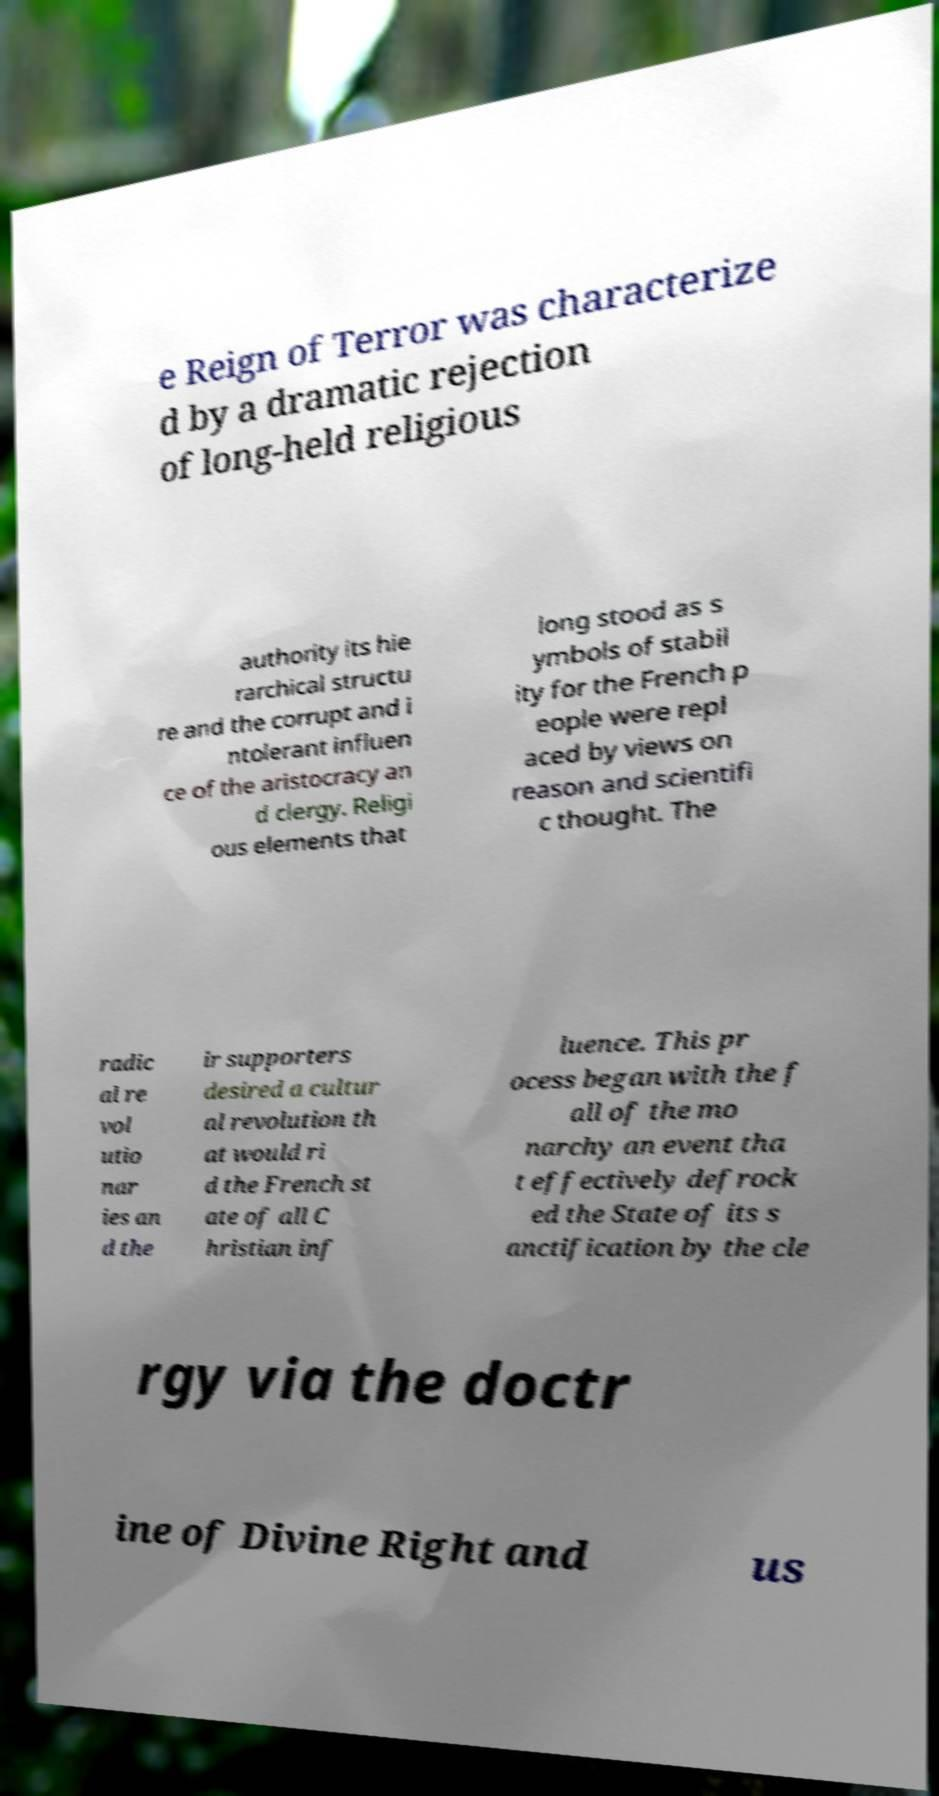Could you extract and type out the text from this image? e Reign of Terror was characterize d by a dramatic rejection of long-held religious authority its hie rarchical structu re and the corrupt and i ntolerant influen ce of the aristocracy an d clergy. Religi ous elements that long stood as s ymbols of stabil ity for the French p eople were repl aced by views on reason and scientifi c thought. The radic al re vol utio nar ies an d the ir supporters desired a cultur al revolution th at would ri d the French st ate of all C hristian inf luence. This pr ocess began with the f all of the mo narchy an event tha t effectively defrock ed the State of its s anctification by the cle rgy via the doctr ine of Divine Right and us 